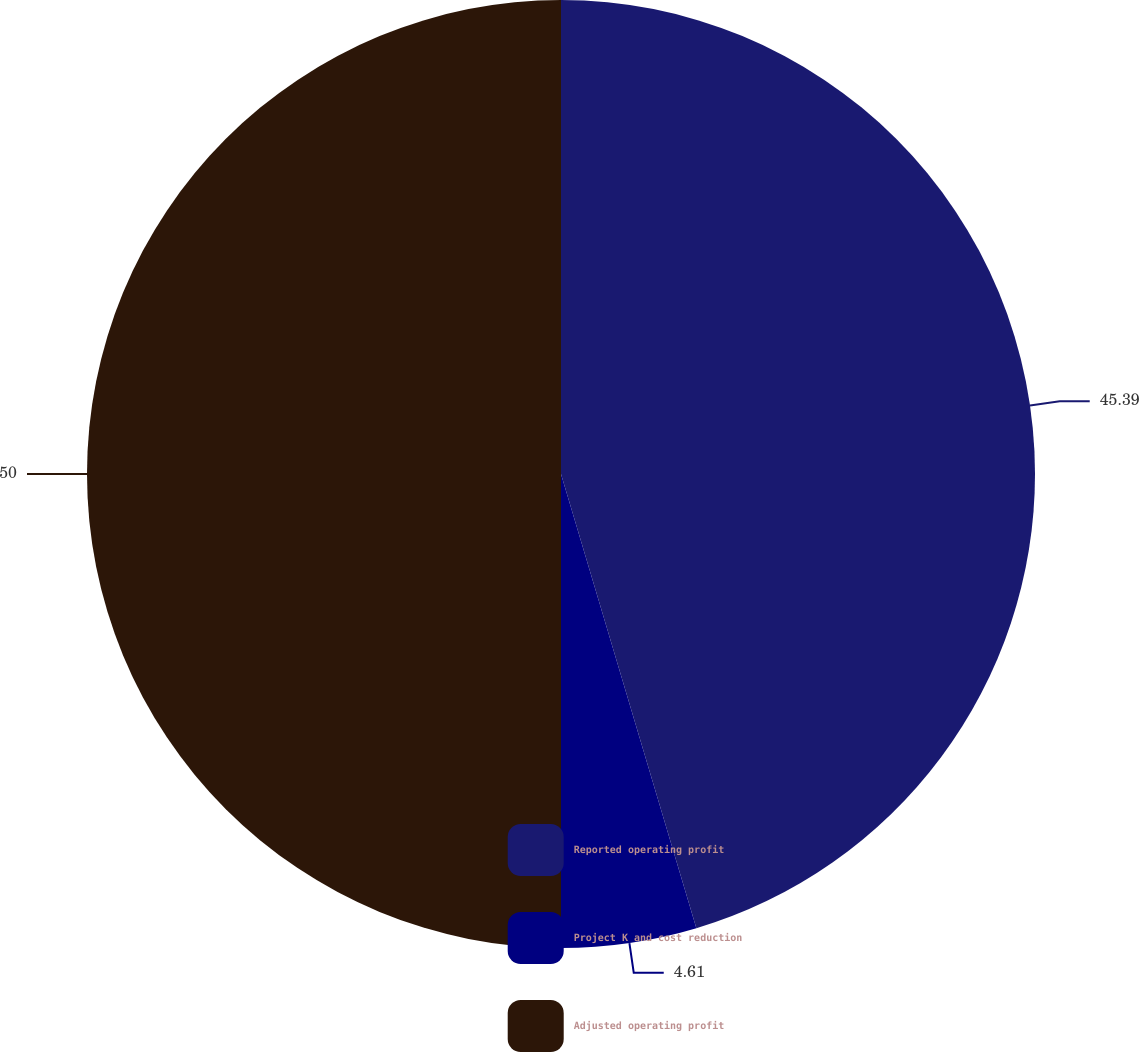Convert chart to OTSL. <chart><loc_0><loc_0><loc_500><loc_500><pie_chart><fcel>Reported operating profit<fcel>Project K and cost reduction<fcel>Adjusted operating profit<nl><fcel>45.39%<fcel>4.61%<fcel>50.0%<nl></chart> 